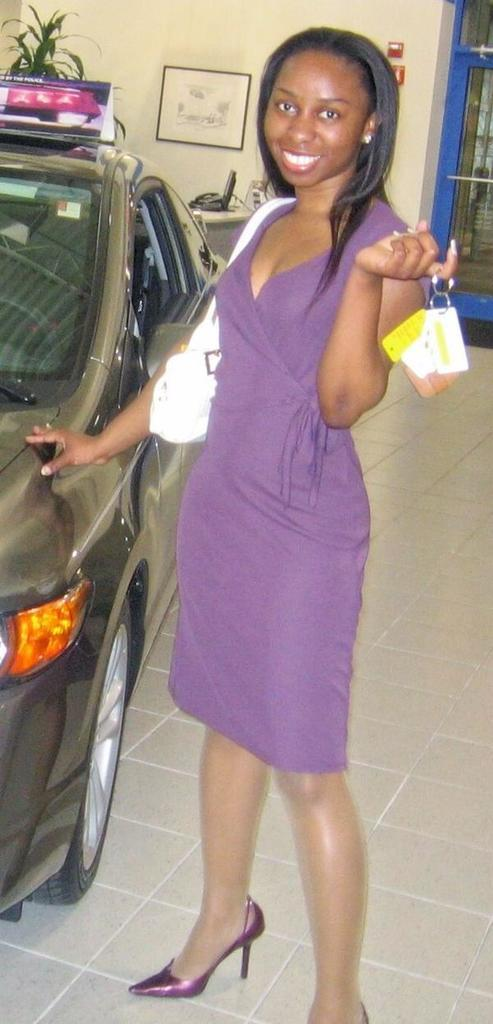Who is present in the image? There is a woman in the image. What is the woman holding in her hand? The woman is holding keys. What can be seen in the background of the image? There is a car, a wall, and a plant in the background of the image. What type of bun is the woman wearing in the image? There is no bun visible on the woman's head in the image. How many marbles can be seen on the ground in the image? There are no marbles present in the image. 